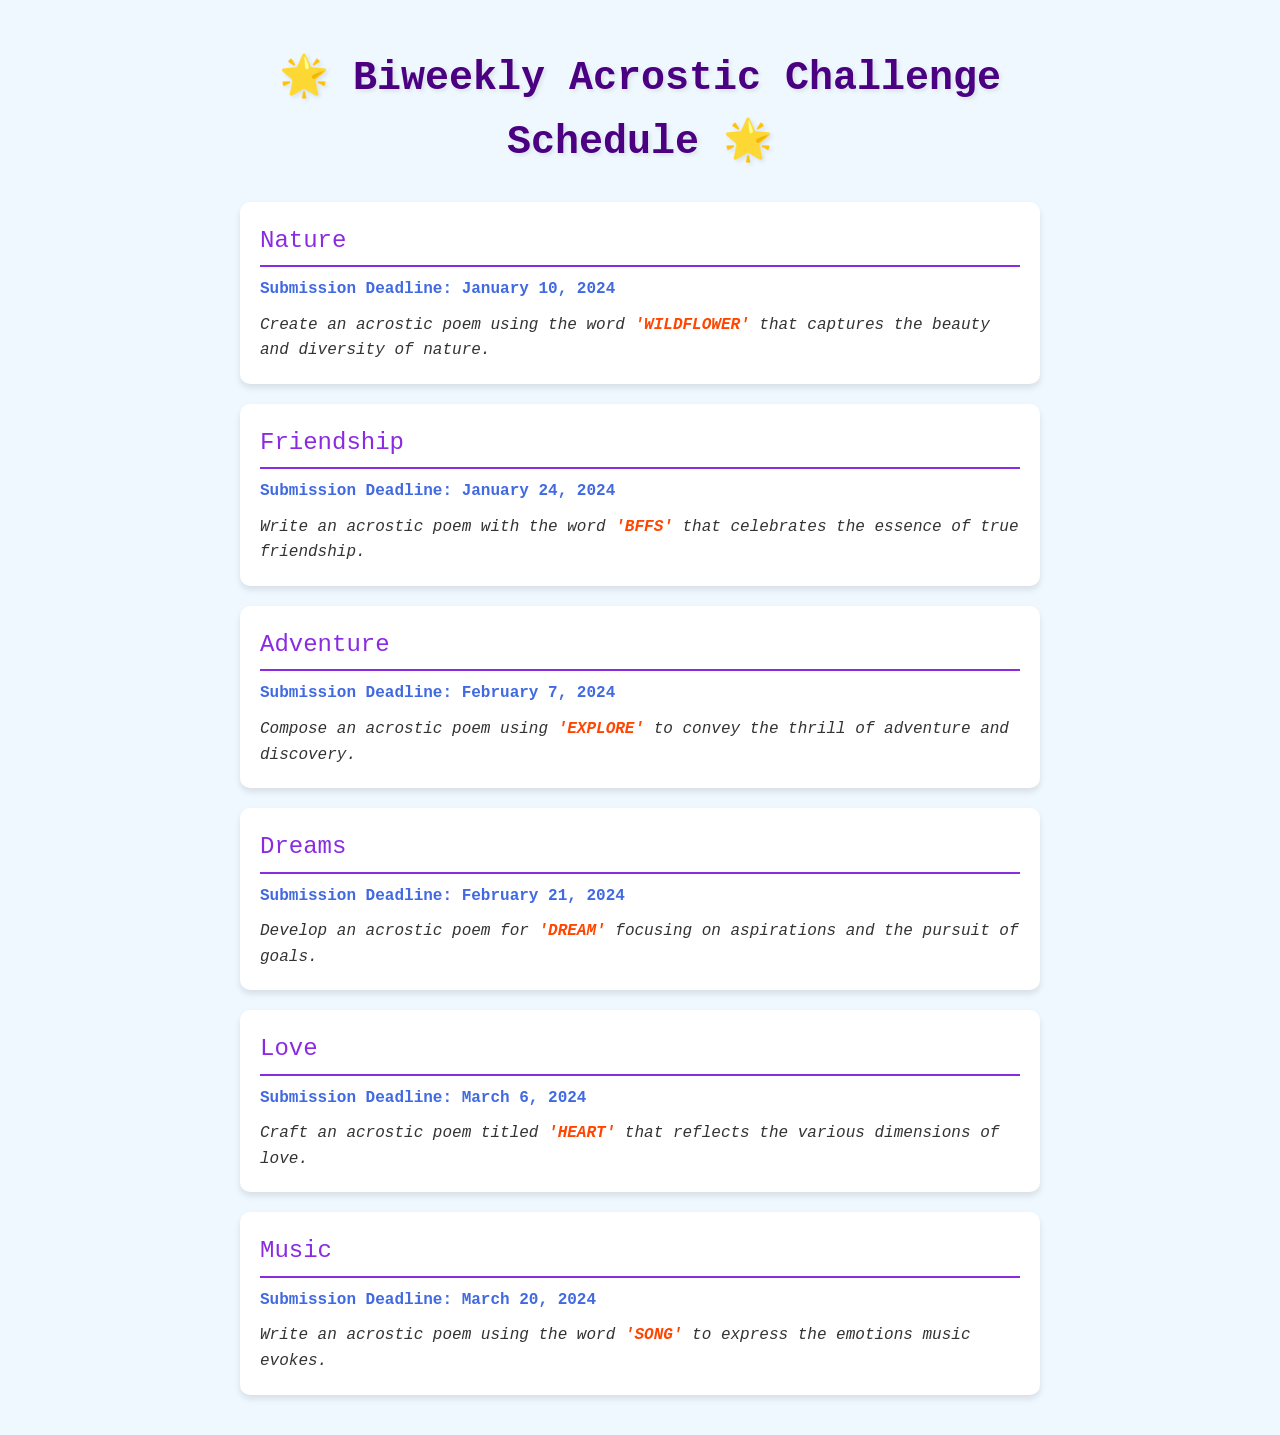what is the first theme of the challenge? The first theme listed in the document is the one associated with the earliest submission deadline, which is "Nature."
Answer: Nature when is the submission deadline for the theme "Adventure"? The document specifies that the submission deadline for "Adventure" is the date mentioned alongside that theme.
Answer: February 7, 2024 what word should the participants use for the theme "Love"? The document details that participants should craft an acrostic poem using the word that corresponds to that theme.
Answer: HEART how many themes are listed in the schedule? The count of themes can be determined by counting each unique theme presented in the document.
Answer: Six which theme's submission deadline is the latest? To find this, we identify which theme's deadline falls after all other themes mentioned in the document.
Answer: Music what is the second word to be used for the theme "Dreams"? This question targets the specific word designated for the acrostic poem for that theme.
Answer: DREAM what is the overall purpose of the document? The document serves to outline a challenge in which participants create acrostic poems based on specified themes and deadlines.
Answer: Acrostic Challenge Schedule when will participants submit their work for the theme "Friendship"? This question pertains to finding the specific submission date tied to that theme.
Answer: January 24, 2024 